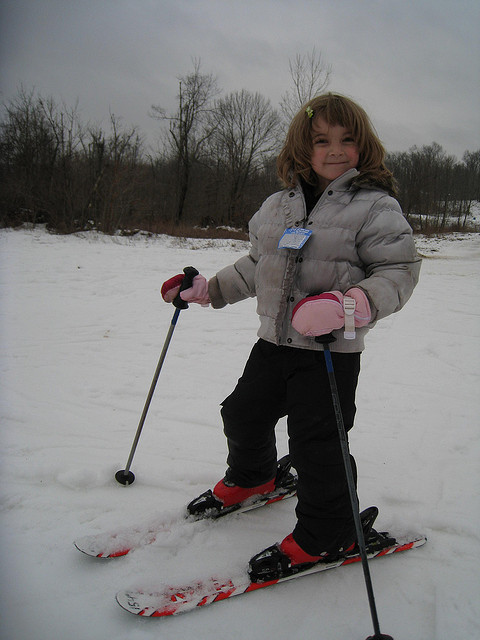<image>Is this picture taken in North Dakota? It is unknown if the picture was taken in North Dakota. Is this picture taken in North Dakota? I don't know if this picture is taken in North Dakota. It is uncertain and can be both yes or no. 